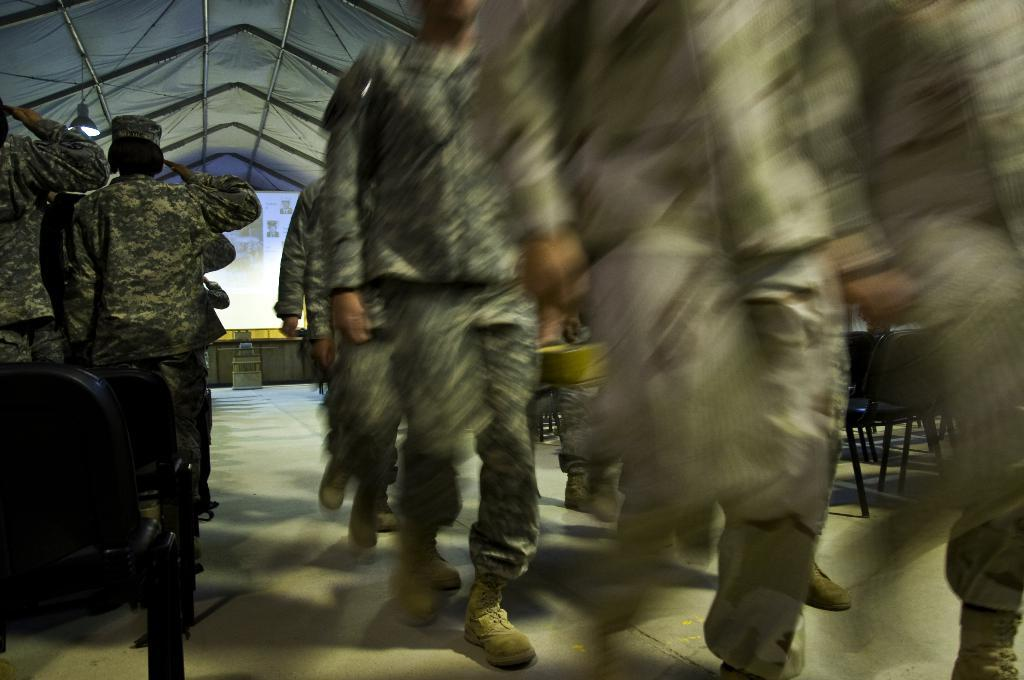How many people can be seen in the image? There are many people standing in the image. What type of chairs are present in the image? There are black chairs in the image. What can be seen in the background of the image? There is a screen and a table in the background of the image. Can you see any waves in the image? There are no waves present in the image. 